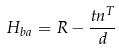<formula> <loc_0><loc_0><loc_500><loc_500>H _ { b a } = R - \frac { t n ^ { T } } { d }</formula> 